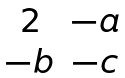Convert formula to latex. <formula><loc_0><loc_0><loc_500><loc_500>\begin{matrix} 2 & - a \\ - b & - c \end{matrix}</formula> 